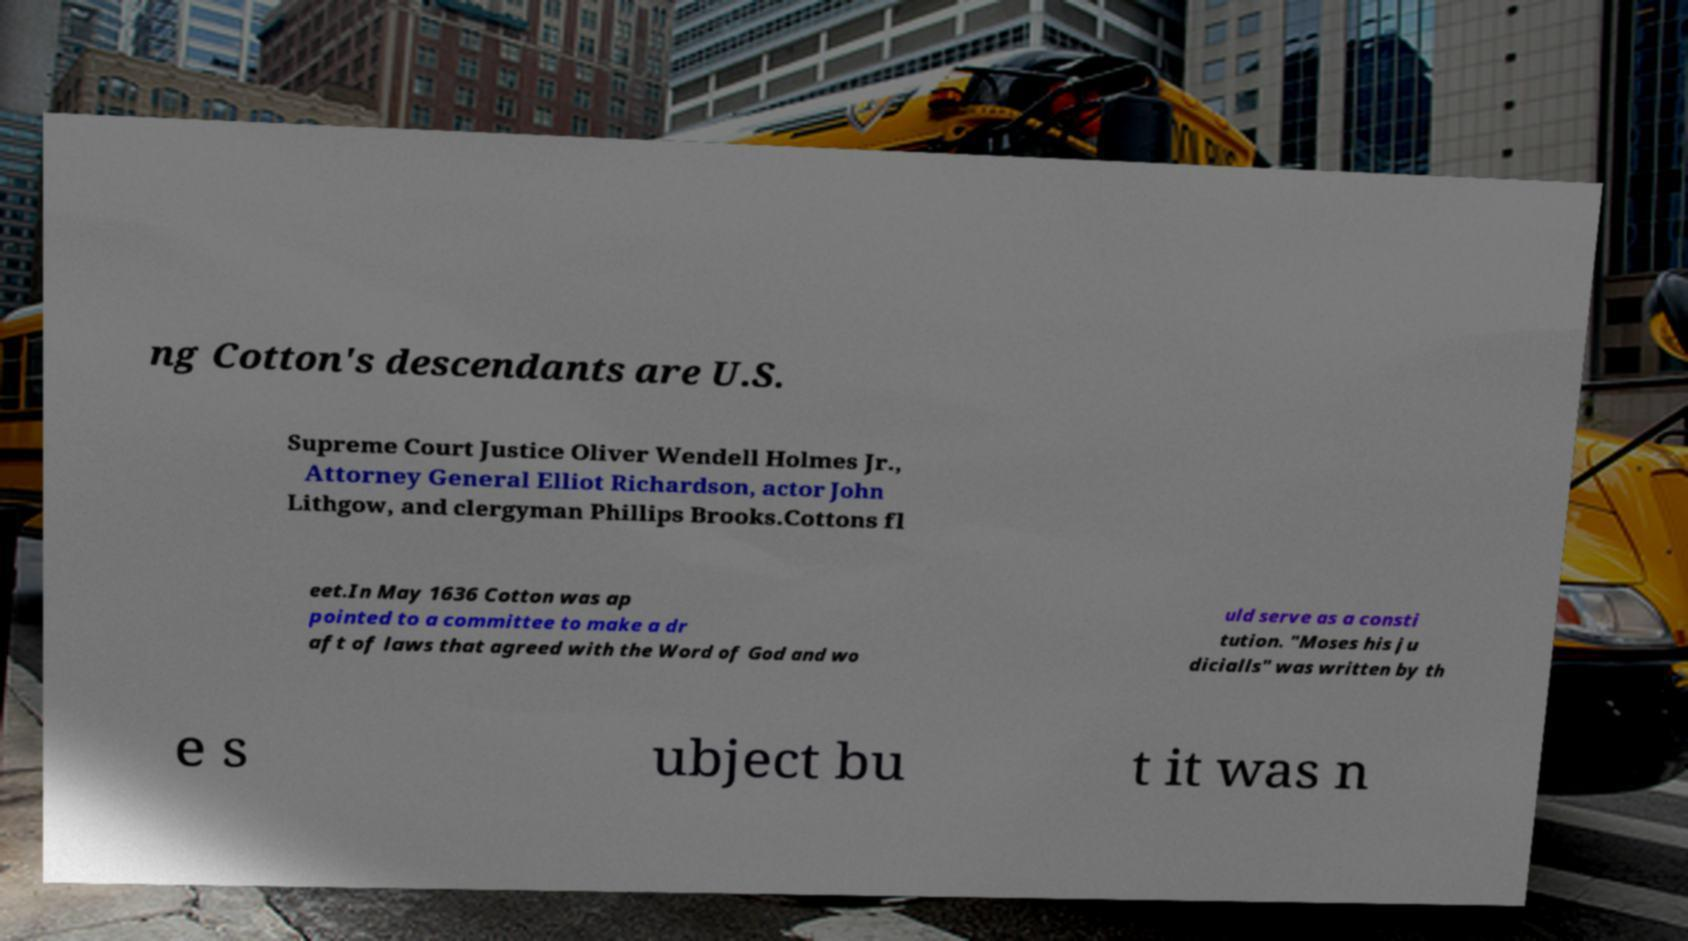Please identify and transcribe the text found in this image. ng Cotton's descendants are U.S. Supreme Court Justice Oliver Wendell Holmes Jr., Attorney General Elliot Richardson, actor John Lithgow, and clergyman Phillips Brooks.Cottons fl eet.In May 1636 Cotton was ap pointed to a committee to make a dr aft of laws that agreed with the Word of God and wo uld serve as a consti tution. "Moses his ju dicialls" was written by th e s ubject bu t it was n 